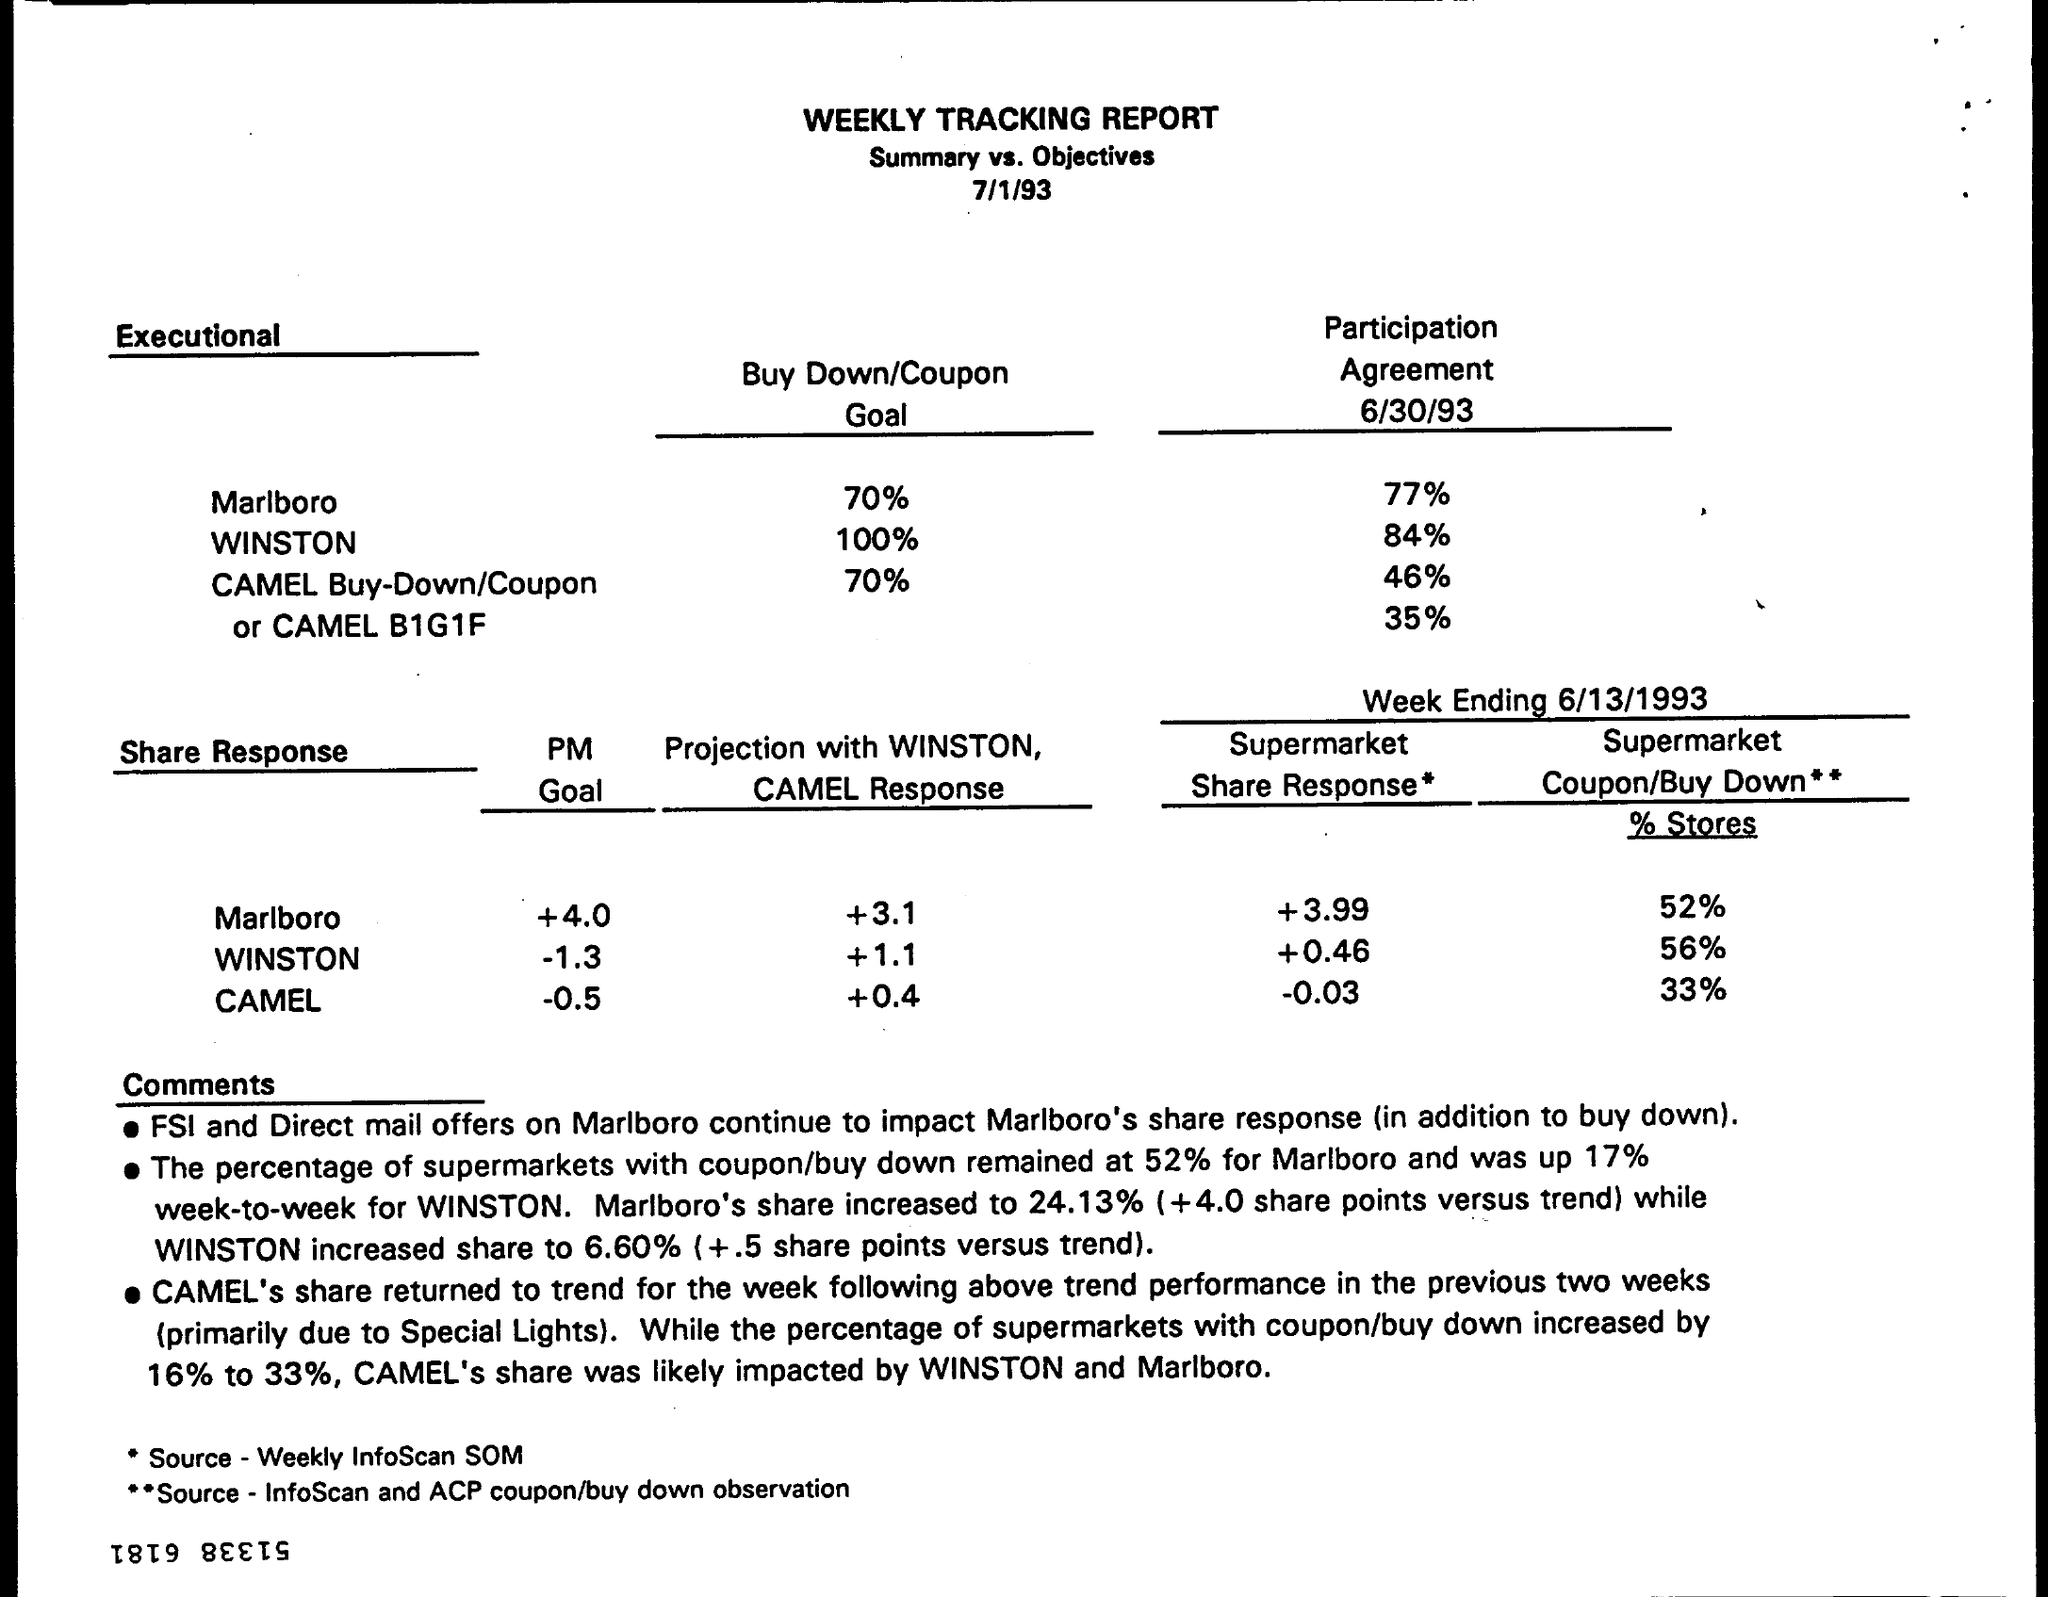Can you describe what the 'Buy Down/Coupon Goal' column is showing? The 'Buy Down/Coupon Goal' column shows targeted percentage goals for promotional activities for each cigarette brand. Marlboro had a target of 70%, WINSTON had a target of 100%, and CAMEL had two targets: 70% for the Buy-Down/Coupon and a special mention of the CAMEL B1G1F (Buy 1 Get 1 Free) offer. 